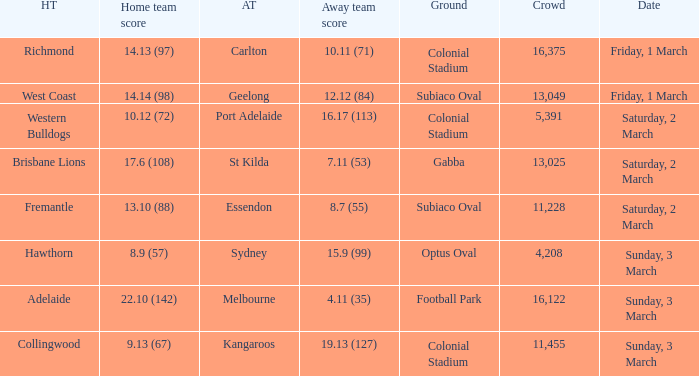When was the guest team geelong? Friday, 1 March. 